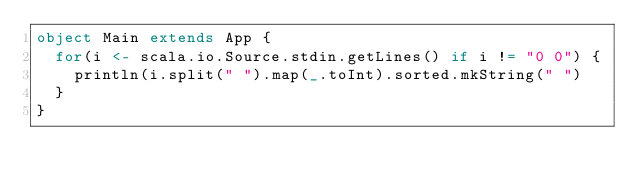<code> <loc_0><loc_0><loc_500><loc_500><_Scala_>object Main extends App {
  for(i <- scala.io.Source.stdin.getLines() if i != "0 0") {
    println(i.split(" ").map(_.toInt).sorted.mkString(" ")
  }
}</code> 